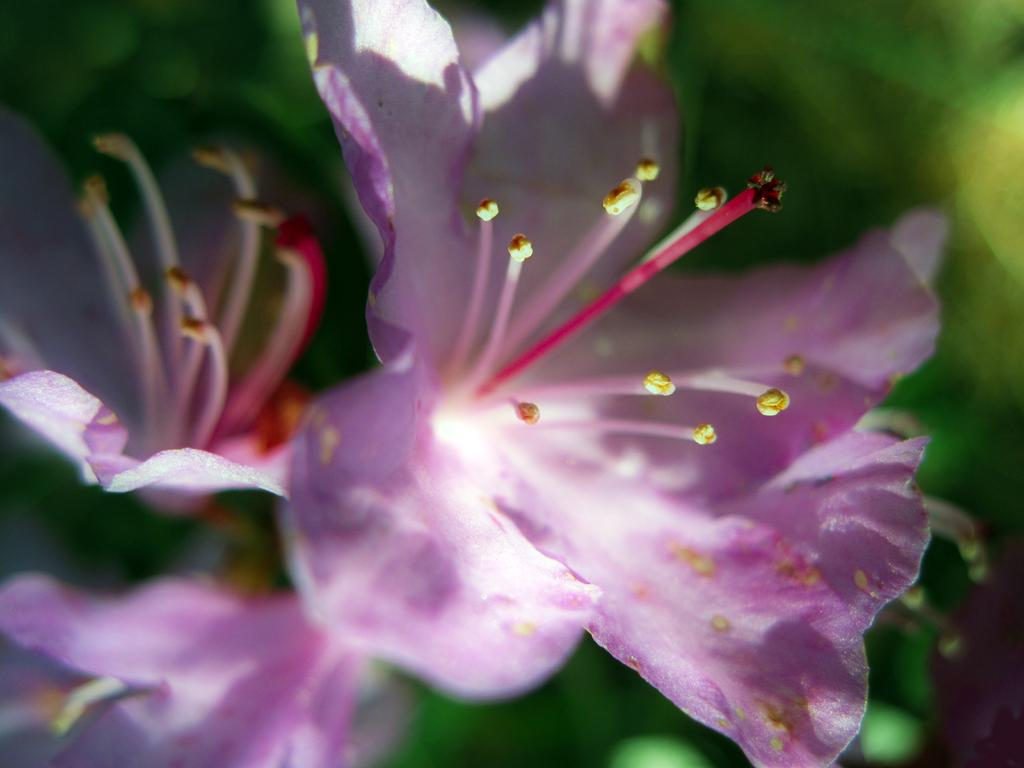What type of plants are present in the image? There are flowers in the image. Can you describe the background of the image? The background behind the flowers is blurred. What type of glass container is holding the flowers in the image? There is no glass container holding the flowers in the image; the flowers are not depicted as being in any container. 